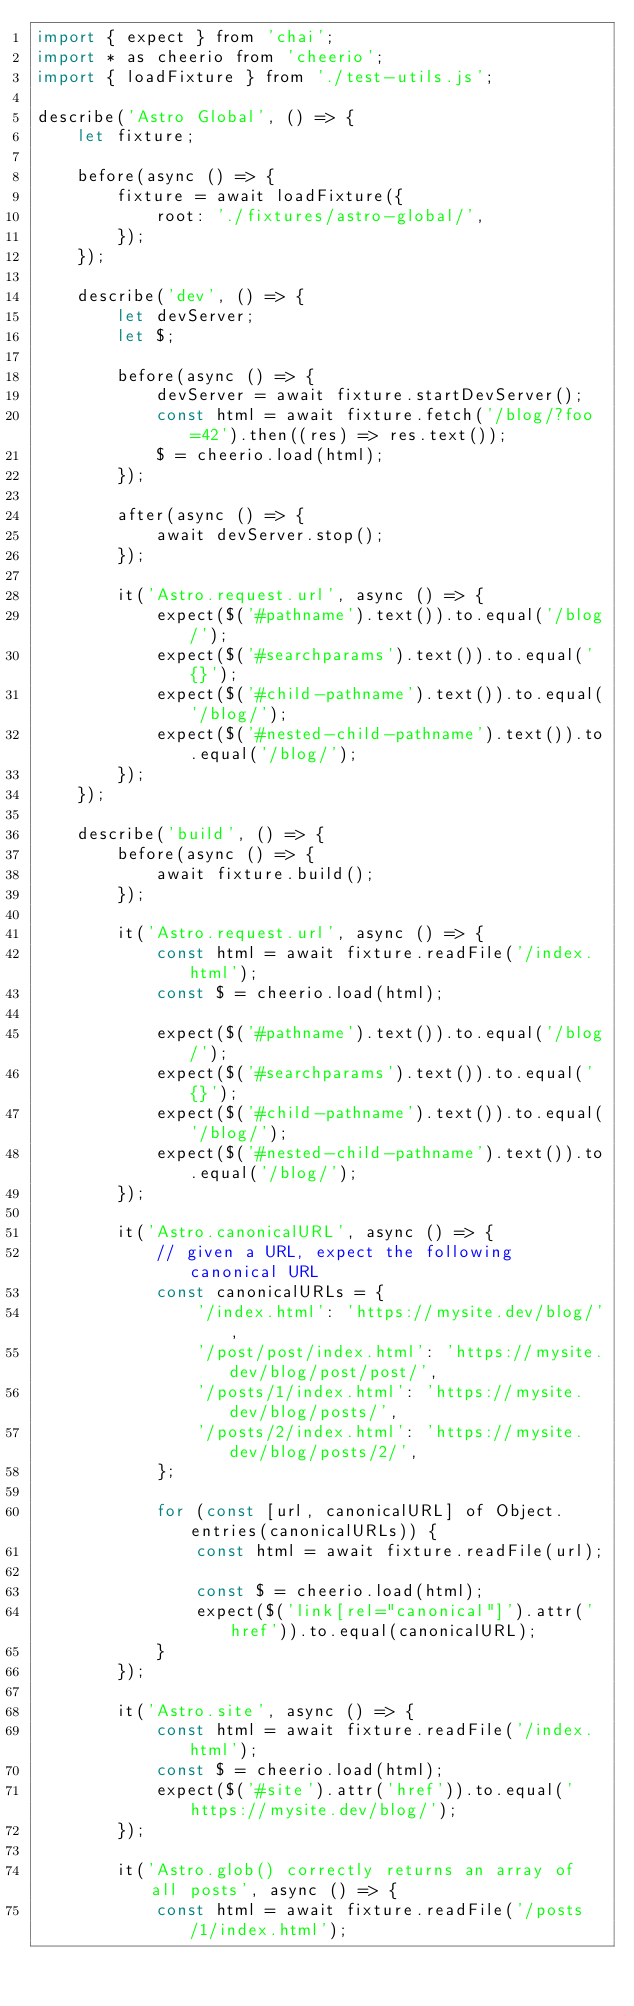<code> <loc_0><loc_0><loc_500><loc_500><_JavaScript_>import { expect } from 'chai';
import * as cheerio from 'cheerio';
import { loadFixture } from './test-utils.js';

describe('Astro Global', () => {
	let fixture;

	before(async () => {
		fixture = await loadFixture({
			root: './fixtures/astro-global/',
		});
	});

	describe('dev', () => {
		let devServer;
		let $;

		before(async () => {
			devServer = await fixture.startDevServer();
			const html = await fixture.fetch('/blog/?foo=42').then((res) => res.text());
			$ = cheerio.load(html);
		});

		after(async () => {
			await devServer.stop();
		});

		it('Astro.request.url', async () => {
			expect($('#pathname').text()).to.equal('/blog/');
			expect($('#searchparams').text()).to.equal('{}');
			expect($('#child-pathname').text()).to.equal('/blog/');
			expect($('#nested-child-pathname').text()).to.equal('/blog/');
		});
	});

	describe('build', () => {
		before(async () => {
			await fixture.build();
		});

		it('Astro.request.url', async () => {
			const html = await fixture.readFile('/index.html');
			const $ = cheerio.load(html);

			expect($('#pathname').text()).to.equal('/blog/');
			expect($('#searchparams').text()).to.equal('{}');
			expect($('#child-pathname').text()).to.equal('/blog/');
			expect($('#nested-child-pathname').text()).to.equal('/blog/');
		});

		it('Astro.canonicalURL', async () => {
			// given a URL, expect the following canonical URL
			const canonicalURLs = {
				'/index.html': 'https://mysite.dev/blog/',
				'/post/post/index.html': 'https://mysite.dev/blog/post/post/',
				'/posts/1/index.html': 'https://mysite.dev/blog/posts/',
				'/posts/2/index.html': 'https://mysite.dev/blog/posts/2/',
			};

			for (const [url, canonicalURL] of Object.entries(canonicalURLs)) {
				const html = await fixture.readFile(url);

				const $ = cheerio.load(html);
				expect($('link[rel="canonical"]').attr('href')).to.equal(canonicalURL);
			}
		});

		it('Astro.site', async () => {
			const html = await fixture.readFile('/index.html');
			const $ = cheerio.load(html);
			expect($('#site').attr('href')).to.equal('https://mysite.dev/blog/');
		});

		it('Astro.glob() correctly returns an array of all posts', async () => {
			const html = await fixture.readFile('/posts/1/index.html');</code> 